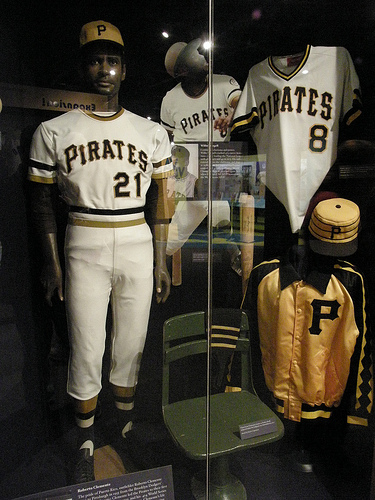<image>
Is there a mannequin in front of the glass? No. The mannequin is not in front of the glass. The spatial positioning shows a different relationship between these objects. 